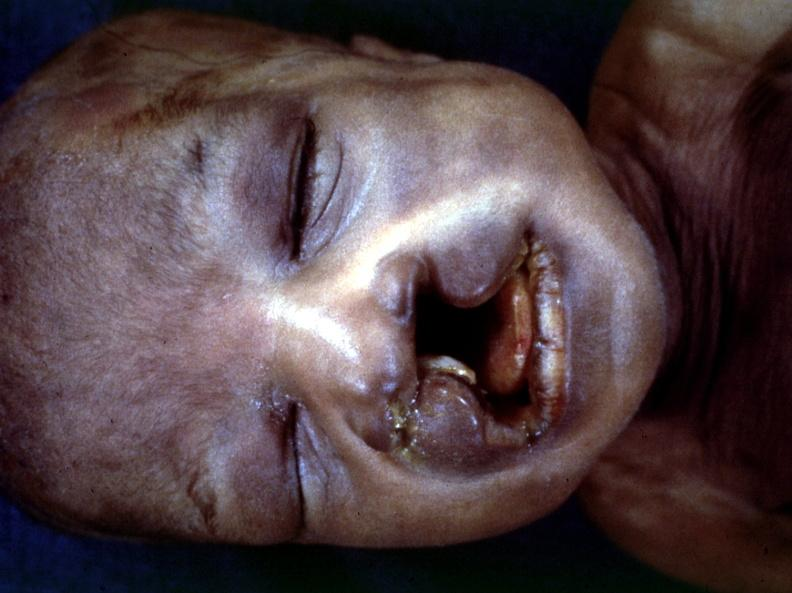s bilateral cleft palate present?
Answer the question using a single word or phrase. Yes 